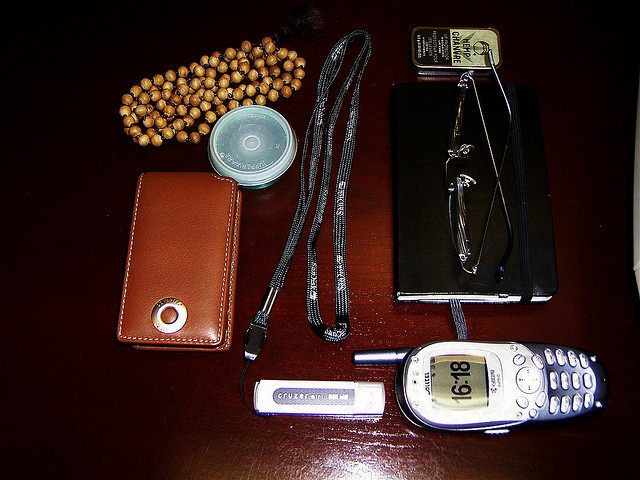Read all the text in this image. CHANVRE Hehp 18 16: cruzer 